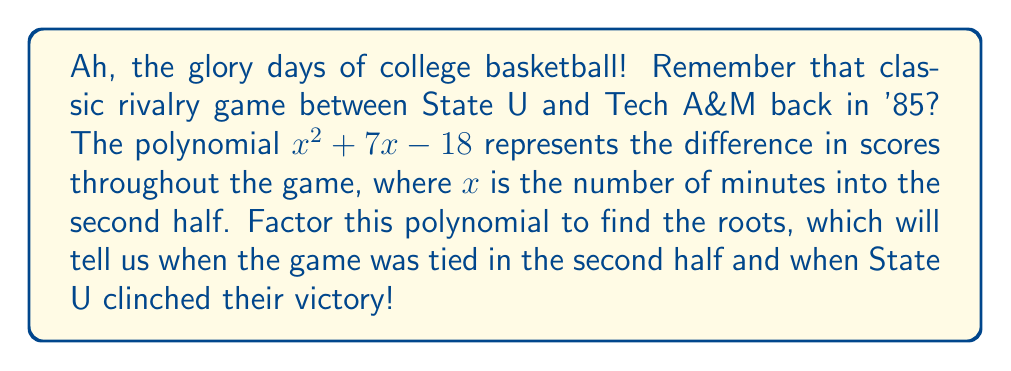Can you answer this question? Let's break this down like we're analyzing game footage, folks:

1) We have a quadratic polynomial in the form $ax^2 + bx + c$, where:
   $a = 1$
   $b = 7$
   $c = -18$

2) To factor this, we're looking for two numbers that multiply to give $ac = 1 \times (-18) = -18$ and add up to $b = 7$.

3) Those numbers are 9 and -2, because $9 \times (-2) = -18$ and $9 + (-2) = 7$.

4) We can rewrite the middle term using these numbers:
   $x^2 + 7x - 18 = x^2 + 9x - 2x - 18$

5) Now we can factor by grouping:
   $(x^2 + 9x) + (-2x - 18)$
   $x(x + 9) - 2(x + 9)$
   $(x - 2)(x + 9)$

6) This gives us our factored form: $(x - 2)(x + 9)$

7) The roots of this polynomial are the values of $x$ that make each factor equal to zero:
   $x - 2 = 0$ or $x + 9 = 0$
   $x = 2$ or $x = -9$

8) Since $x$ represents minutes into the second half, we can interpret these results:
   - The game was tied 2 minutes into the second half.
   - The negative root (-9) doesn't have a meaningful interpretation in this context.
Answer: $(x - 2)(x + 9)$ 